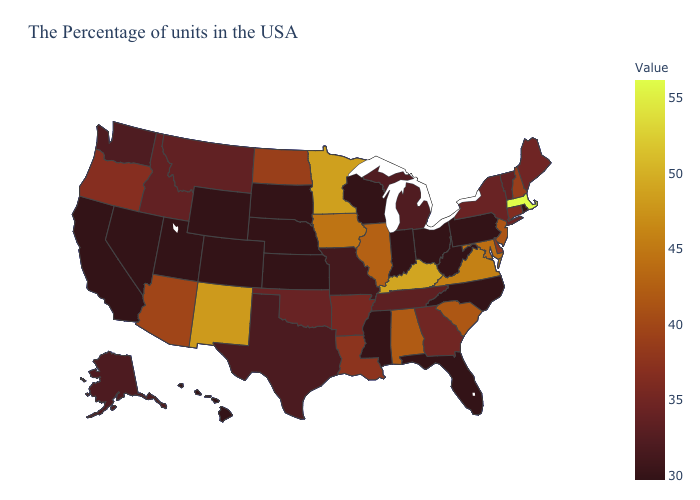Among the states that border New York , which have the lowest value?
Concise answer only. Pennsylvania. Does the map have missing data?
Write a very short answer. No. Does the map have missing data?
Be succinct. No. Among the states that border New Hampshire , which have the highest value?
Keep it brief. Massachusetts. 